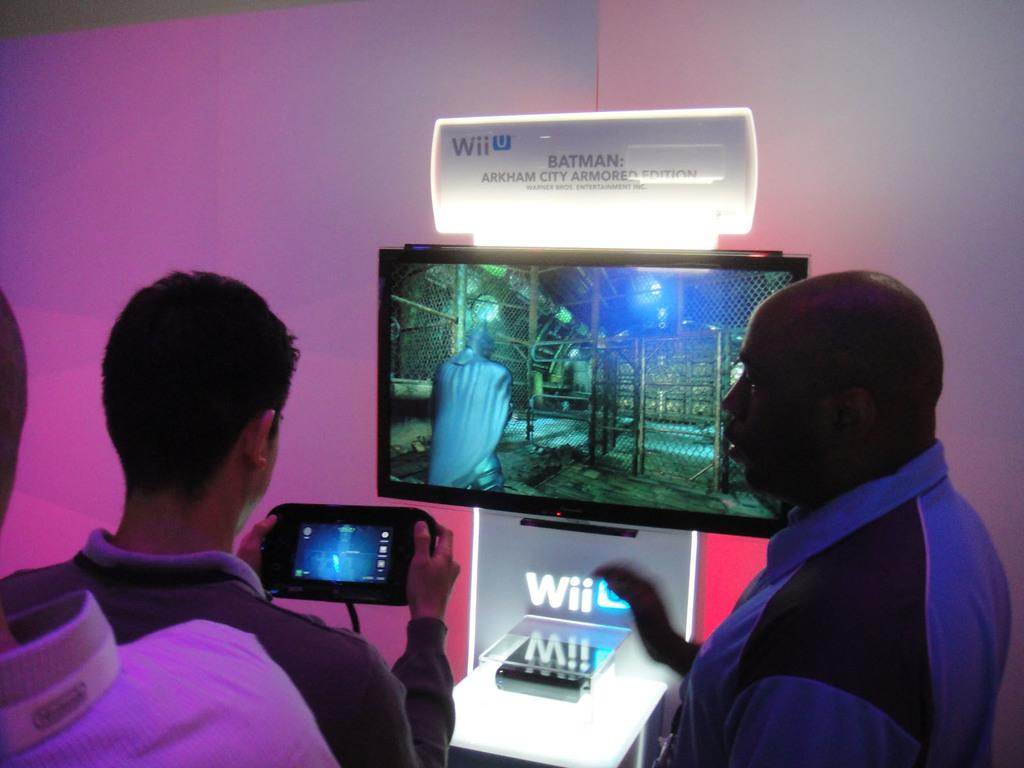<image>
Present a compact description of the photo's key features. Two people are playing a WiiU that is on display. 